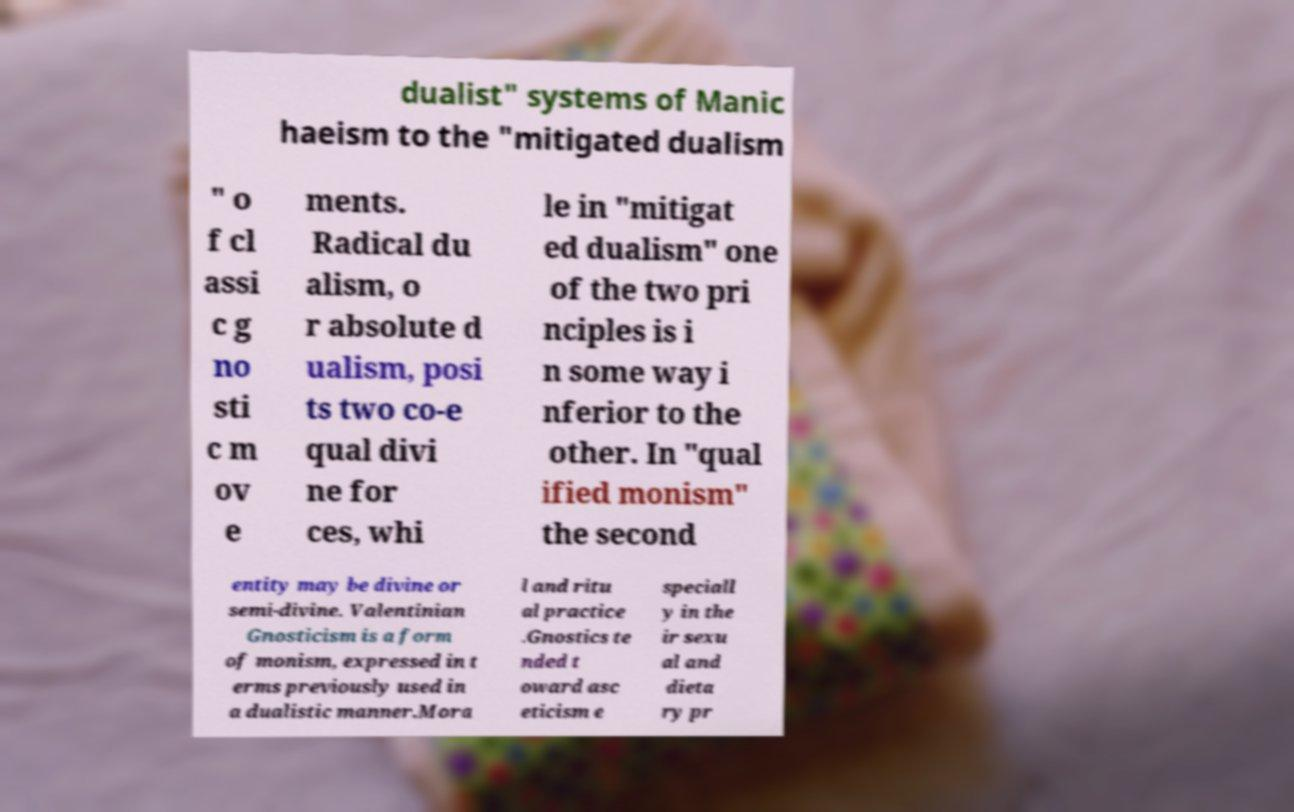There's text embedded in this image that I need extracted. Can you transcribe it verbatim? dualist" systems of Manic haeism to the "mitigated dualism " o f cl assi c g no sti c m ov e ments. Radical du alism, o r absolute d ualism, posi ts two co-e qual divi ne for ces, whi le in "mitigat ed dualism" one of the two pri nciples is i n some way i nferior to the other. In "qual ified monism" the second entity may be divine or semi-divine. Valentinian Gnosticism is a form of monism, expressed in t erms previously used in a dualistic manner.Mora l and ritu al practice .Gnostics te nded t oward asc eticism e speciall y in the ir sexu al and dieta ry pr 